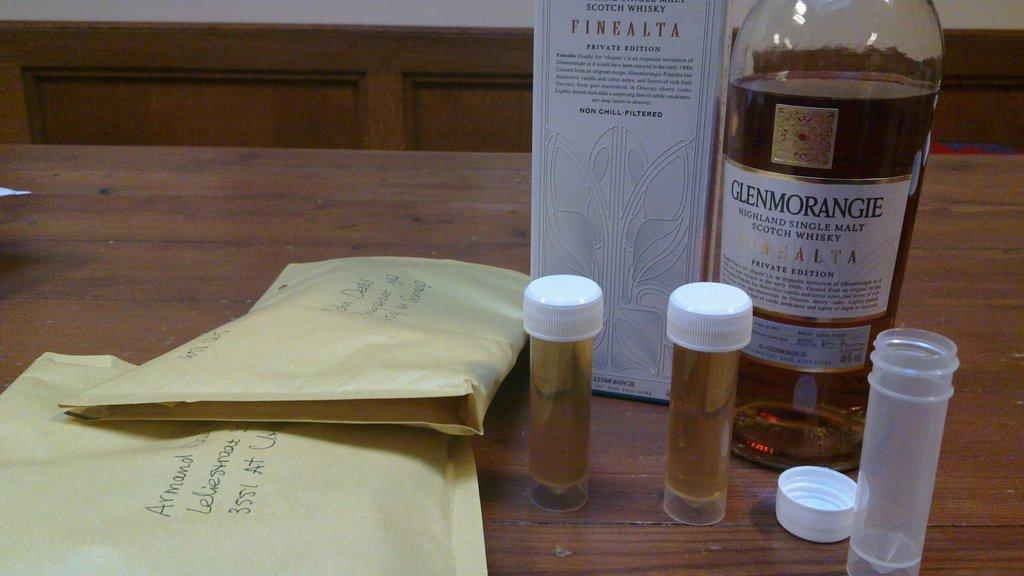<image>
Give a short and clear explanation of the subsequent image. A bottle of Glenmorangie Single Malt Scotch Whiskey and 3 test tubes. 